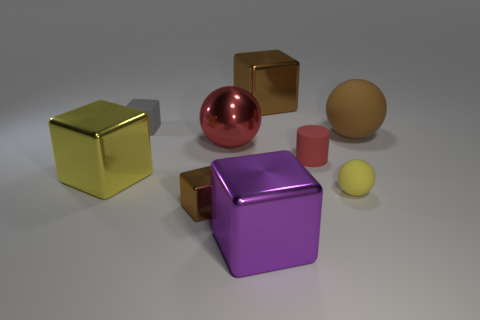There is a shiny object that is on the left side of the gray matte cube; how big is it?
Provide a succinct answer. Large. The thing that is both right of the red matte object and in front of the big brown rubber sphere has what shape?
Your response must be concise. Sphere. What size is the purple object that is the same shape as the large yellow object?
Your answer should be compact. Large. How many tiny gray blocks have the same material as the yellow ball?
Provide a short and direct response. 1. Does the big matte ball have the same color as the rubber object in front of the red rubber cylinder?
Provide a short and direct response. No. Are there more large purple things than tiny brown matte blocks?
Make the answer very short. Yes. What color is the small ball?
Your answer should be very brief. Yellow. Is the color of the large thing that is on the left side of the red metal object the same as the small cylinder?
Give a very brief answer. No. There is a thing that is the same color as the small cylinder; what is it made of?
Give a very brief answer. Metal. What number of large things have the same color as the matte cylinder?
Provide a short and direct response. 1. 